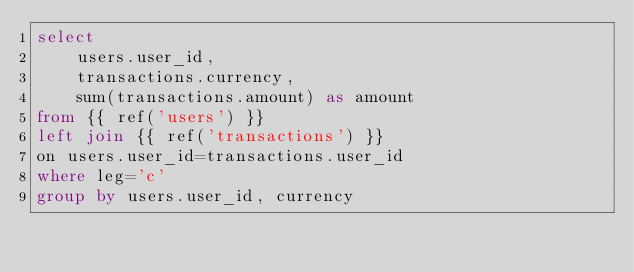Convert code to text. <code><loc_0><loc_0><loc_500><loc_500><_SQL_>select
    users.user_id,
    transactions.currency,
    sum(transactions.amount) as amount
from {{ ref('users') }}
left join {{ ref('transactions') }}
on users.user_id=transactions.user_id
where leg='c'
group by users.user_id, currency
</code> 